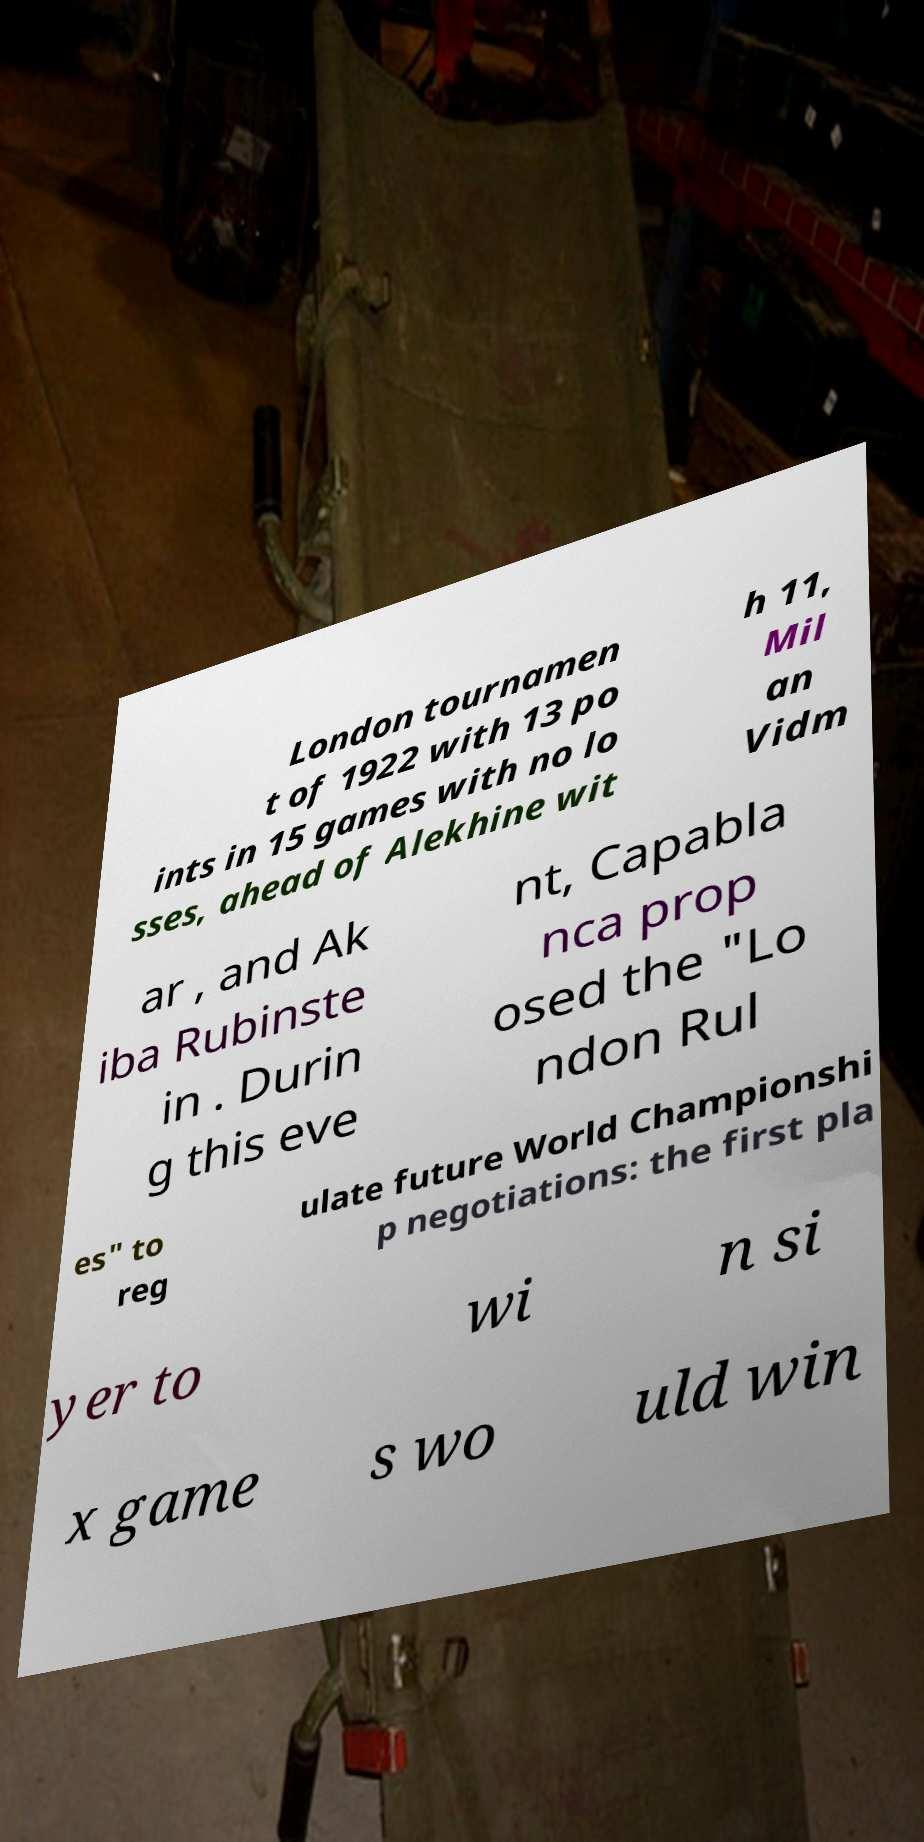For documentation purposes, I need the text within this image transcribed. Could you provide that? London tournamen t of 1922 with 13 po ints in 15 games with no lo sses, ahead of Alekhine wit h 11, Mil an Vidm ar , and Ak iba Rubinste in . Durin g this eve nt, Capabla nca prop osed the "Lo ndon Rul es" to reg ulate future World Championshi p negotiations: the first pla yer to wi n si x game s wo uld win 